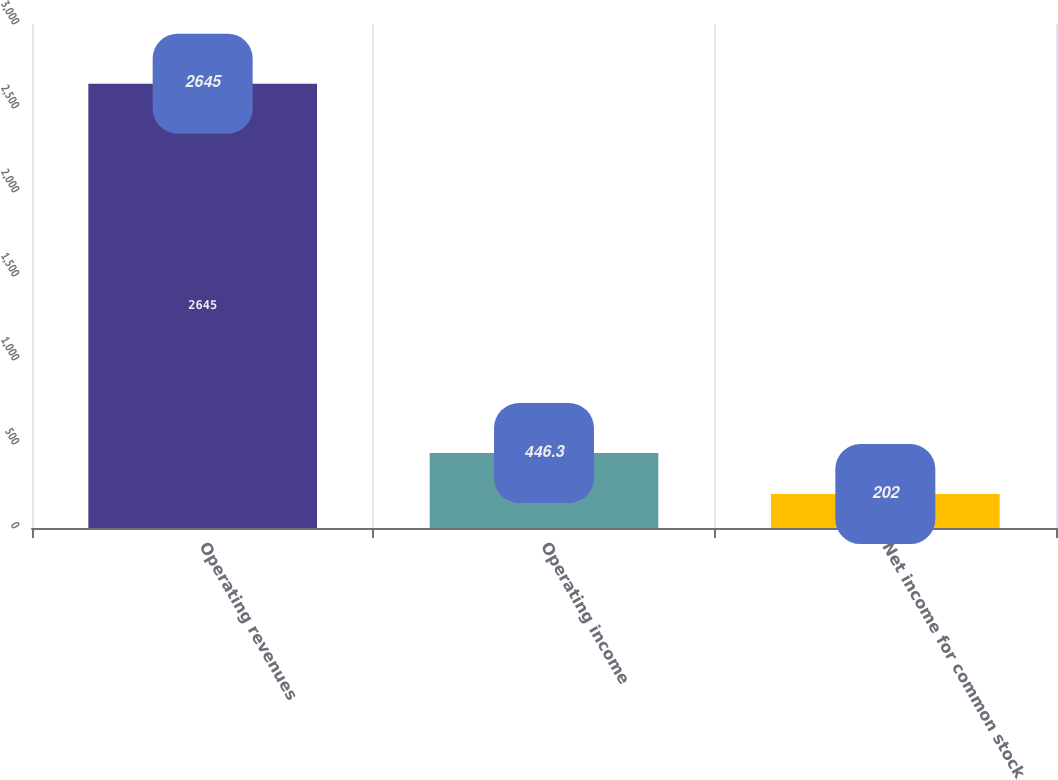Convert chart to OTSL. <chart><loc_0><loc_0><loc_500><loc_500><bar_chart><fcel>Operating revenues<fcel>Operating income<fcel>Net income for common stock<nl><fcel>2645<fcel>446.3<fcel>202<nl></chart> 